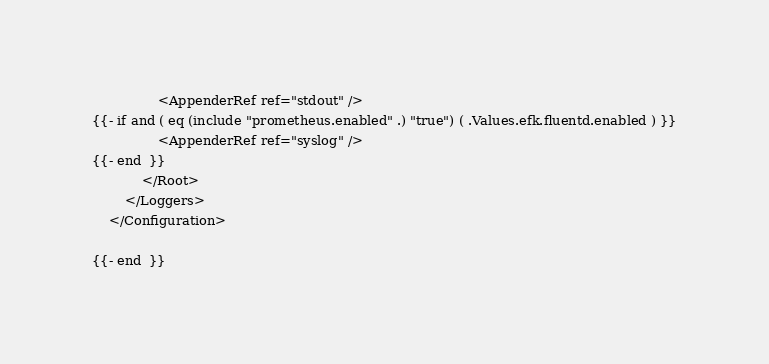Convert code to text. <code><loc_0><loc_0><loc_500><loc_500><_YAML_>                <AppenderRef ref="stdout" />
{{- if and ( eq (include "prometheus.enabled" .) "true") ( .Values.efk.fluentd.enabled ) }}
                <AppenderRef ref="syslog" />
{{- end  }}
            </Root>
        </Loggers>
    </Configuration>

{{- end  }}</code> 